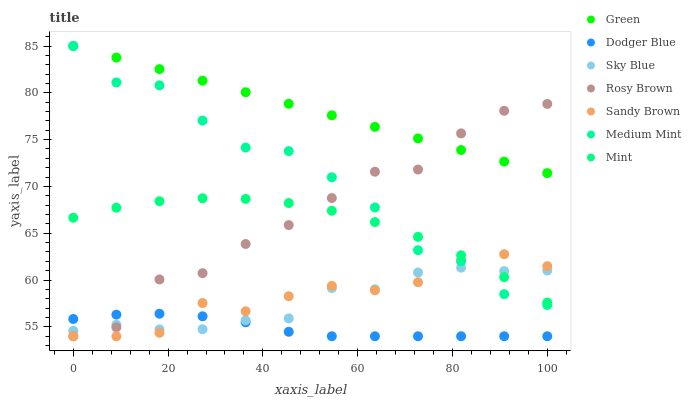Does Dodger Blue have the minimum area under the curve?
Answer yes or no. Yes. Does Green have the maximum area under the curve?
Answer yes or no. Yes. Does Mint have the minimum area under the curve?
Answer yes or no. No. Does Mint have the maximum area under the curve?
Answer yes or no. No. Is Green the smoothest?
Answer yes or no. Yes. Is Medium Mint the roughest?
Answer yes or no. Yes. Is Mint the smoothest?
Answer yes or no. No. Is Mint the roughest?
Answer yes or no. No. Does Rosy Brown have the lowest value?
Answer yes or no. Yes. Does Mint have the lowest value?
Answer yes or no. No. Does Green have the highest value?
Answer yes or no. Yes. Does Mint have the highest value?
Answer yes or no. No. Is Dodger Blue less than Mint?
Answer yes or no. Yes. Is Green greater than Mint?
Answer yes or no. Yes. Does Dodger Blue intersect Sky Blue?
Answer yes or no. Yes. Is Dodger Blue less than Sky Blue?
Answer yes or no. No. Is Dodger Blue greater than Sky Blue?
Answer yes or no. No. Does Dodger Blue intersect Mint?
Answer yes or no. No. 